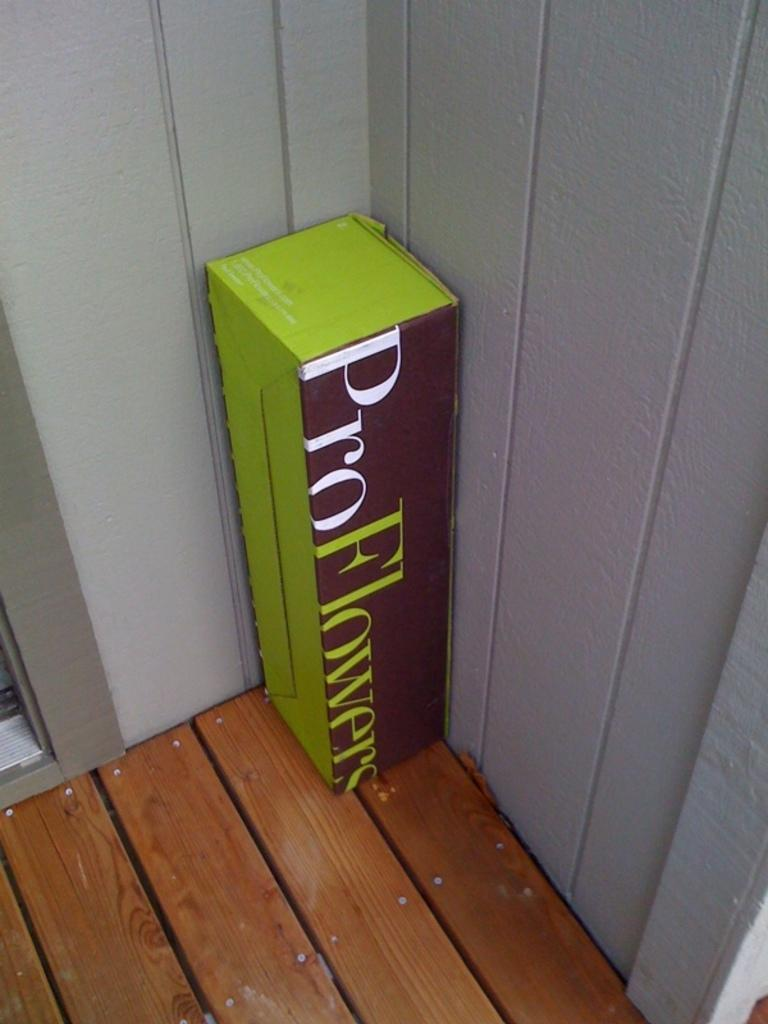<image>
Summarize the visual content of the image. A box from Pro Flowers sits in the corner of a porch. 